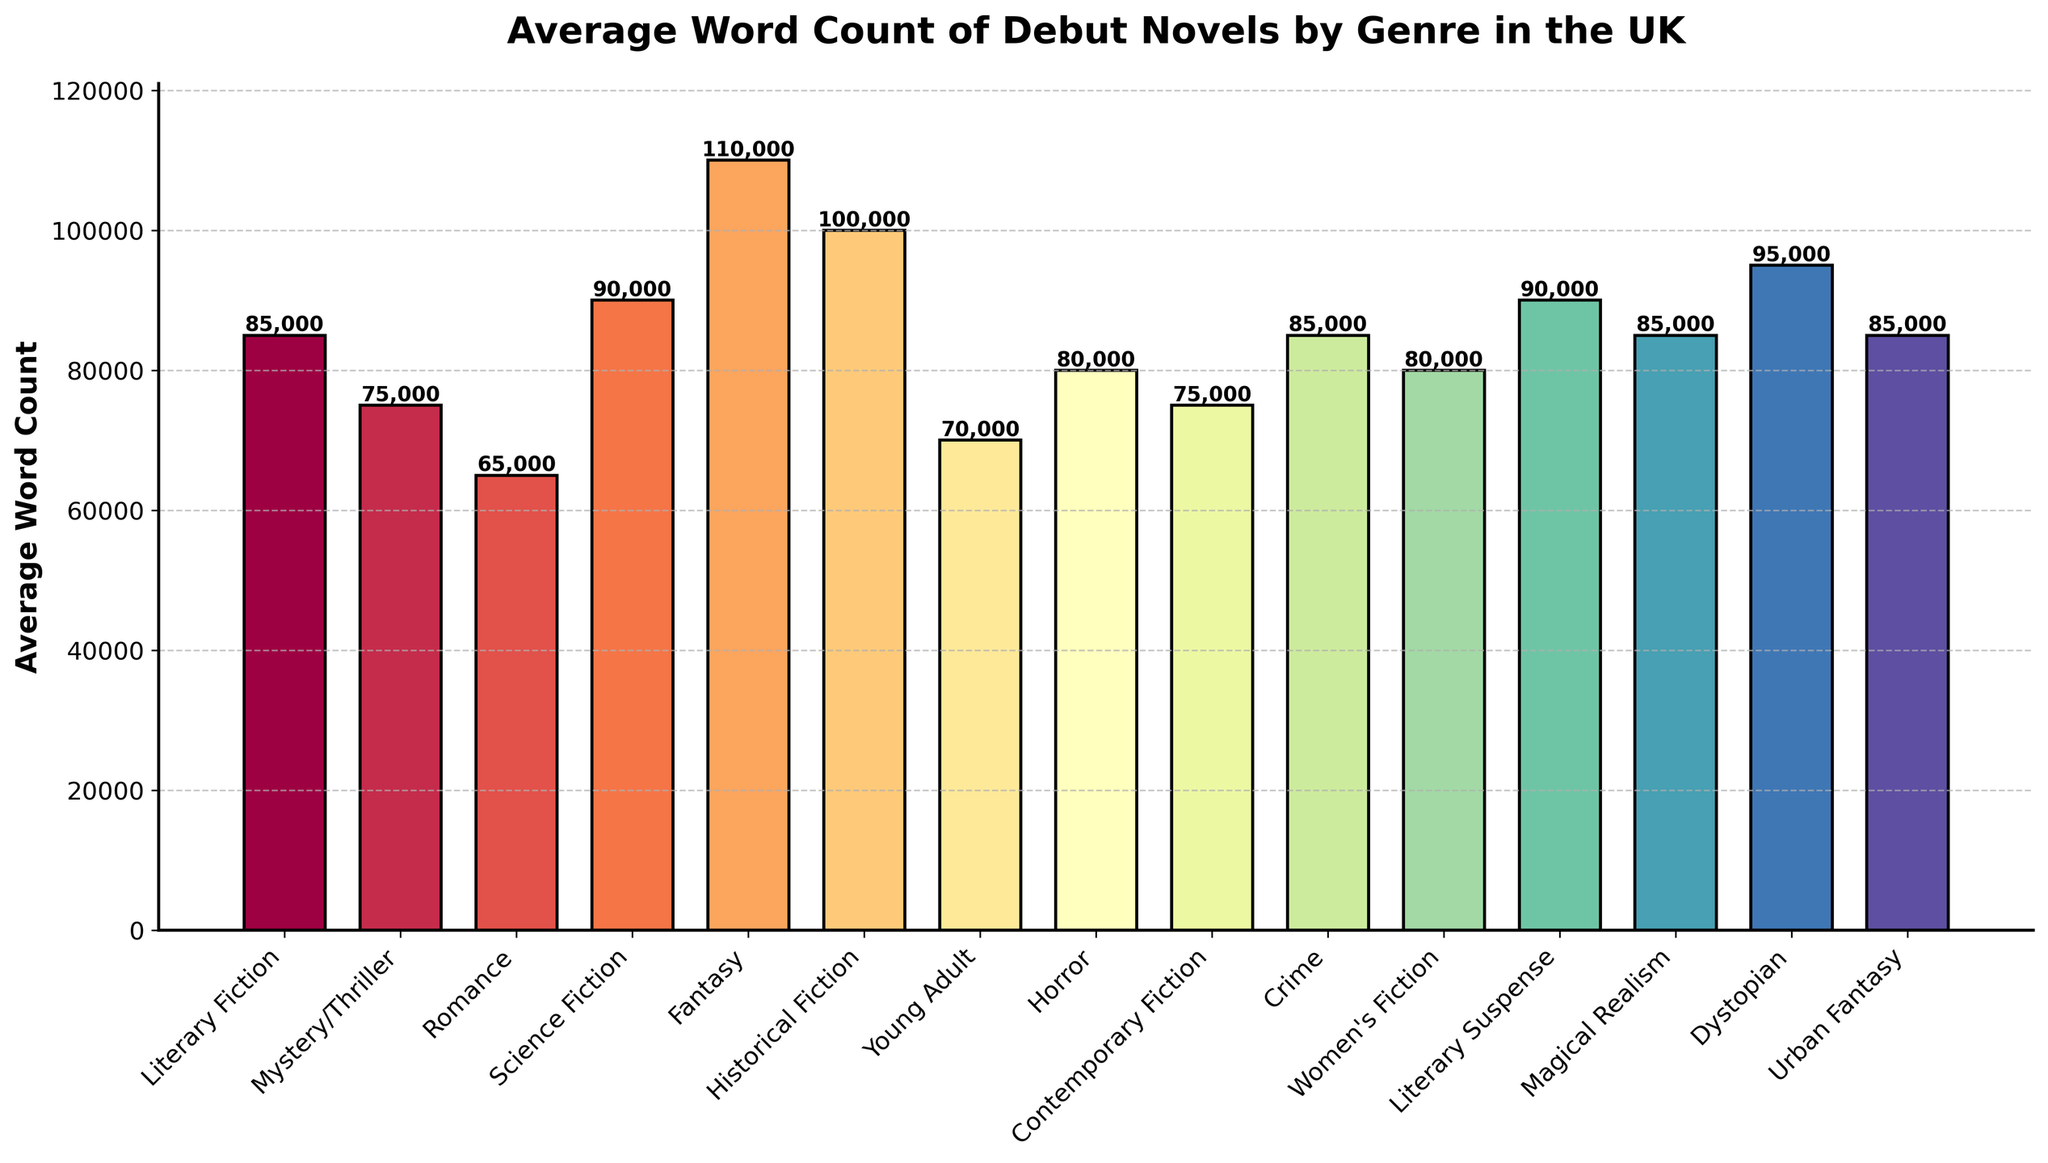What's the genre with the highest average word count? Based on the height of the bars, Fantasy has the highest bar, indicating the highest average word count.
Answer: Fantasy Compare the average word count between Science Fiction and Fantasy. Which one is greater, and by how much? Fantasy has a higher average word count (110,000) than Science Fiction (90,000). The difference is calculated as 110,000 - 90,000.
Answer: Fantasy by 20,000 Which genre has a lower average word count: Romance or Contemporary Fiction? By comparing the heights of the bars, Romance has an average word count of 65,000, while Contemporary Fiction has 75,000. Romance is lower.
Answer: Romance What is the mean average word count for Literary Fiction, Mystery/Thriller, Crime, and Literary Suspense? Sum the average word counts 85,000 (Literary Fiction) + 75,000 (Mystery/Thriller) + 85,000 (Crime) + 90,000 (Literary Suspense) = 335,000. Divide by the number of genres, 4.
Answer: 83,750 If you combine the average word counts of Horror and Women's Fiction, will the sum be greater than the average word count of Historical Fiction? The sum of Horror (80,000) and Women’s Fiction (80,000) is 160,000, which is greater than Historical Fiction (100,000).
Answer: Yes Which genres have an equal average word count of 85,000? Identify the bars that reach the same height at 85,000. Both Literary Fiction, Crime, Magical Realism, and Urban Fantasy share this value.
Answer: Literary Fiction, Crime, Magical Realism, Urban Fantasy Find the median average word count for all genres depicted in the chart. Organize all average word counts in ascending order and find the middle value(s). The sorted order is 65,000 (Romance), 70,000 (Young Adult), 75,000 (Mystery/Thriller), 75,000 (Contemporary Fiction), 80,000 (Horror), 80,000 (Women’s Fiction), 85,000 (Literary Fiction), 85,000 (Crime), 85,000 (Magical Realism), 85,000 (Urban Fantasy), 90,000 (Science Fiction), 90,000 (Literary Suspense), 95,000 (Dystopian), 100,000 (Historical Fiction), 110,000 (Fantasy). The middle values are 85,000 and 85,000.
Answer: 85,000 What percentage of genres have an average word count of 80,000? There are 3 genres (Horror, Women's Fiction) with an average word count of 80,000 out of a total of 15 genres. Calculate (3/15) * 100.
Answer: 20% What is the total sum of the average word counts for Dystopian, Urban Fantasy, and Historical Fiction? Sum the average word counts: 95,000 (Dystopian) + 85,000 (Urban Fantasy) + 100,000 (Historical Fiction) = 280,000.
Answer: 280,000 